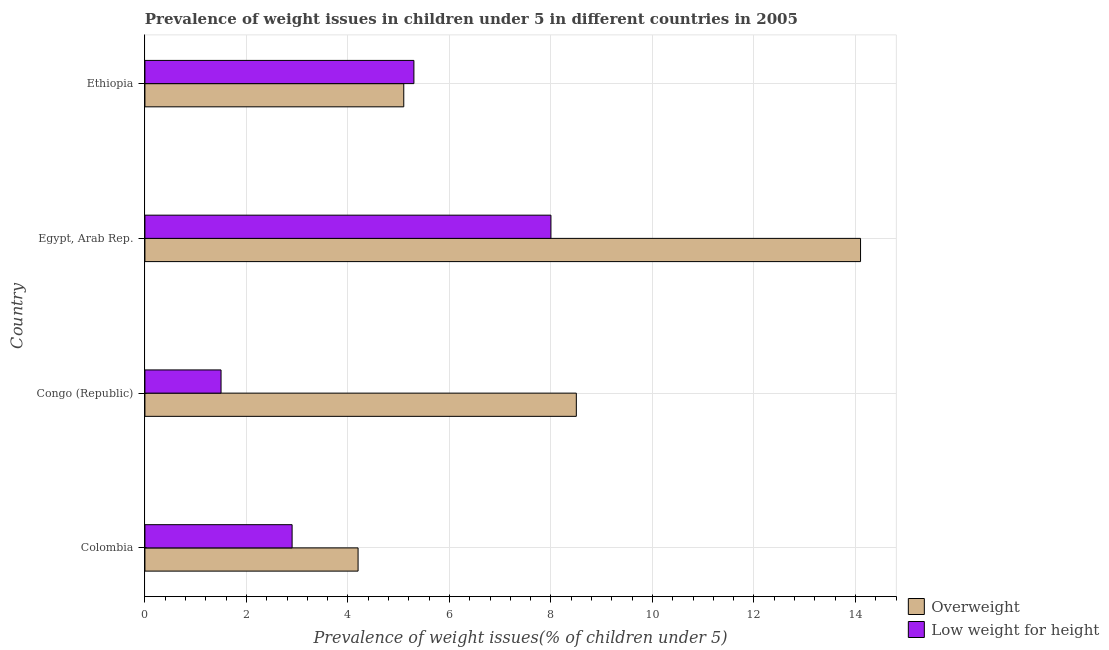How many different coloured bars are there?
Provide a succinct answer. 2. How many groups of bars are there?
Make the answer very short. 4. Are the number of bars per tick equal to the number of legend labels?
Offer a very short reply. Yes. How many bars are there on the 2nd tick from the top?
Your answer should be very brief. 2. How many bars are there on the 1st tick from the bottom?
Your answer should be very brief. 2. What is the label of the 3rd group of bars from the top?
Your response must be concise. Congo (Republic). What is the percentage of underweight children in Egypt, Arab Rep.?
Your answer should be compact. 8. Across all countries, what is the maximum percentage of overweight children?
Keep it short and to the point. 14.1. Across all countries, what is the minimum percentage of overweight children?
Provide a short and direct response. 4.2. In which country was the percentage of overweight children maximum?
Provide a succinct answer. Egypt, Arab Rep. What is the total percentage of overweight children in the graph?
Your answer should be very brief. 31.9. What is the difference between the percentage of underweight children in Congo (Republic) and that in Ethiopia?
Provide a succinct answer. -3.8. What is the difference between the percentage of underweight children in Ethiopia and the percentage of overweight children in Colombia?
Make the answer very short. 1.1. What is the average percentage of overweight children per country?
Offer a terse response. 7.97. What is the ratio of the percentage of overweight children in Colombia to that in Congo (Republic)?
Offer a very short reply. 0.49. Is the difference between the percentage of underweight children in Egypt, Arab Rep. and Ethiopia greater than the difference between the percentage of overweight children in Egypt, Arab Rep. and Ethiopia?
Make the answer very short. No. In how many countries, is the percentage of overweight children greater than the average percentage of overweight children taken over all countries?
Your response must be concise. 2. What does the 1st bar from the top in Colombia represents?
Keep it short and to the point. Low weight for height. What does the 1st bar from the bottom in Colombia represents?
Your answer should be compact. Overweight. How many bars are there?
Provide a short and direct response. 8. Are the values on the major ticks of X-axis written in scientific E-notation?
Provide a short and direct response. No. Does the graph contain any zero values?
Ensure brevity in your answer.  No. Does the graph contain grids?
Provide a succinct answer. Yes. Where does the legend appear in the graph?
Give a very brief answer. Bottom right. How many legend labels are there?
Keep it short and to the point. 2. How are the legend labels stacked?
Ensure brevity in your answer.  Vertical. What is the title of the graph?
Provide a short and direct response. Prevalence of weight issues in children under 5 in different countries in 2005. What is the label or title of the X-axis?
Offer a very short reply. Prevalence of weight issues(% of children under 5). What is the label or title of the Y-axis?
Provide a succinct answer. Country. What is the Prevalence of weight issues(% of children under 5) of Overweight in Colombia?
Provide a succinct answer. 4.2. What is the Prevalence of weight issues(% of children under 5) of Low weight for height in Colombia?
Make the answer very short. 2.9. What is the Prevalence of weight issues(% of children under 5) of Overweight in Congo (Republic)?
Ensure brevity in your answer.  8.5. What is the Prevalence of weight issues(% of children under 5) of Overweight in Egypt, Arab Rep.?
Your response must be concise. 14.1. What is the Prevalence of weight issues(% of children under 5) in Overweight in Ethiopia?
Provide a succinct answer. 5.1. What is the Prevalence of weight issues(% of children under 5) in Low weight for height in Ethiopia?
Make the answer very short. 5.3. Across all countries, what is the maximum Prevalence of weight issues(% of children under 5) of Overweight?
Your answer should be compact. 14.1. Across all countries, what is the minimum Prevalence of weight issues(% of children under 5) in Overweight?
Provide a succinct answer. 4.2. What is the total Prevalence of weight issues(% of children under 5) of Overweight in the graph?
Provide a succinct answer. 31.9. What is the total Prevalence of weight issues(% of children under 5) in Low weight for height in the graph?
Offer a terse response. 17.7. What is the difference between the Prevalence of weight issues(% of children under 5) of Overweight in Colombia and that in Congo (Republic)?
Your answer should be very brief. -4.3. What is the difference between the Prevalence of weight issues(% of children under 5) in Low weight for height in Colombia and that in Ethiopia?
Provide a short and direct response. -2.4. What is the difference between the Prevalence of weight issues(% of children under 5) in Overweight in Congo (Republic) and that in Egypt, Arab Rep.?
Offer a terse response. -5.6. What is the difference between the Prevalence of weight issues(% of children under 5) in Overweight in Congo (Republic) and that in Ethiopia?
Your answer should be compact. 3.4. What is the difference between the Prevalence of weight issues(% of children under 5) in Overweight in Colombia and the Prevalence of weight issues(% of children under 5) in Low weight for height in Egypt, Arab Rep.?
Ensure brevity in your answer.  -3.8. What is the difference between the Prevalence of weight issues(% of children under 5) of Overweight in Congo (Republic) and the Prevalence of weight issues(% of children under 5) of Low weight for height in Egypt, Arab Rep.?
Provide a succinct answer. 0.5. What is the difference between the Prevalence of weight issues(% of children under 5) in Overweight in Egypt, Arab Rep. and the Prevalence of weight issues(% of children under 5) in Low weight for height in Ethiopia?
Your answer should be very brief. 8.8. What is the average Prevalence of weight issues(% of children under 5) of Overweight per country?
Your response must be concise. 7.97. What is the average Prevalence of weight issues(% of children under 5) in Low weight for height per country?
Make the answer very short. 4.42. What is the difference between the Prevalence of weight issues(% of children under 5) of Overweight and Prevalence of weight issues(% of children under 5) of Low weight for height in Egypt, Arab Rep.?
Offer a terse response. 6.1. What is the difference between the Prevalence of weight issues(% of children under 5) in Overweight and Prevalence of weight issues(% of children under 5) in Low weight for height in Ethiopia?
Provide a succinct answer. -0.2. What is the ratio of the Prevalence of weight issues(% of children under 5) in Overweight in Colombia to that in Congo (Republic)?
Offer a very short reply. 0.49. What is the ratio of the Prevalence of weight issues(% of children under 5) in Low weight for height in Colombia to that in Congo (Republic)?
Offer a very short reply. 1.93. What is the ratio of the Prevalence of weight issues(% of children under 5) of Overweight in Colombia to that in Egypt, Arab Rep.?
Offer a very short reply. 0.3. What is the ratio of the Prevalence of weight issues(% of children under 5) in Low weight for height in Colombia to that in Egypt, Arab Rep.?
Your answer should be compact. 0.36. What is the ratio of the Prevalence of weight issues(% of children under 5) in Overweight in Colombia to that in Ethiopia?
Give a very brief answer. 0.82. What is the ratio of the Prevalence of weight issues(% of children under 5) of Low weight for height in Colombia to that in Ethiopia?
Offer a very short reply. 0.55. What is the ratio of the Prevalence of weight issues(% of children under 5) in Overweight in Congo (Republic) to that in Egypt, Arab Rep.?
Make the answer very short. 0.6. What is the ratio of the Prevalence of weight issues(% of children under 5) of Low weight for height in Congo (Republic) to that in Egypt, Arab Rep.?
Ensure brevity in your answer.  0.19. What is the ratio of the Prevalence of weight issues(% of children under 5) of Low weight for height in Congo (Republic) to that in Ethiopia?
Offer a terse response. 0.28. What is the ratio of the Prevalence of weight issues(% of children under 5) of Overweight in Egypt, Arab Rep. to that in Ethiopia?
Offer a very short reply. 2.76. What is the ratio of the Prevalence of weight issues(% of children under 5) of Low weight for height in Egypt, Arab Rep. to that in Ethiopia?
Your answer should be very brief. 1.51. What is the difference between the highest and the second highest Prevalence of weight issues(% of children under 5) in Overweight?
Ensure brevity in your answer.  5.6. 